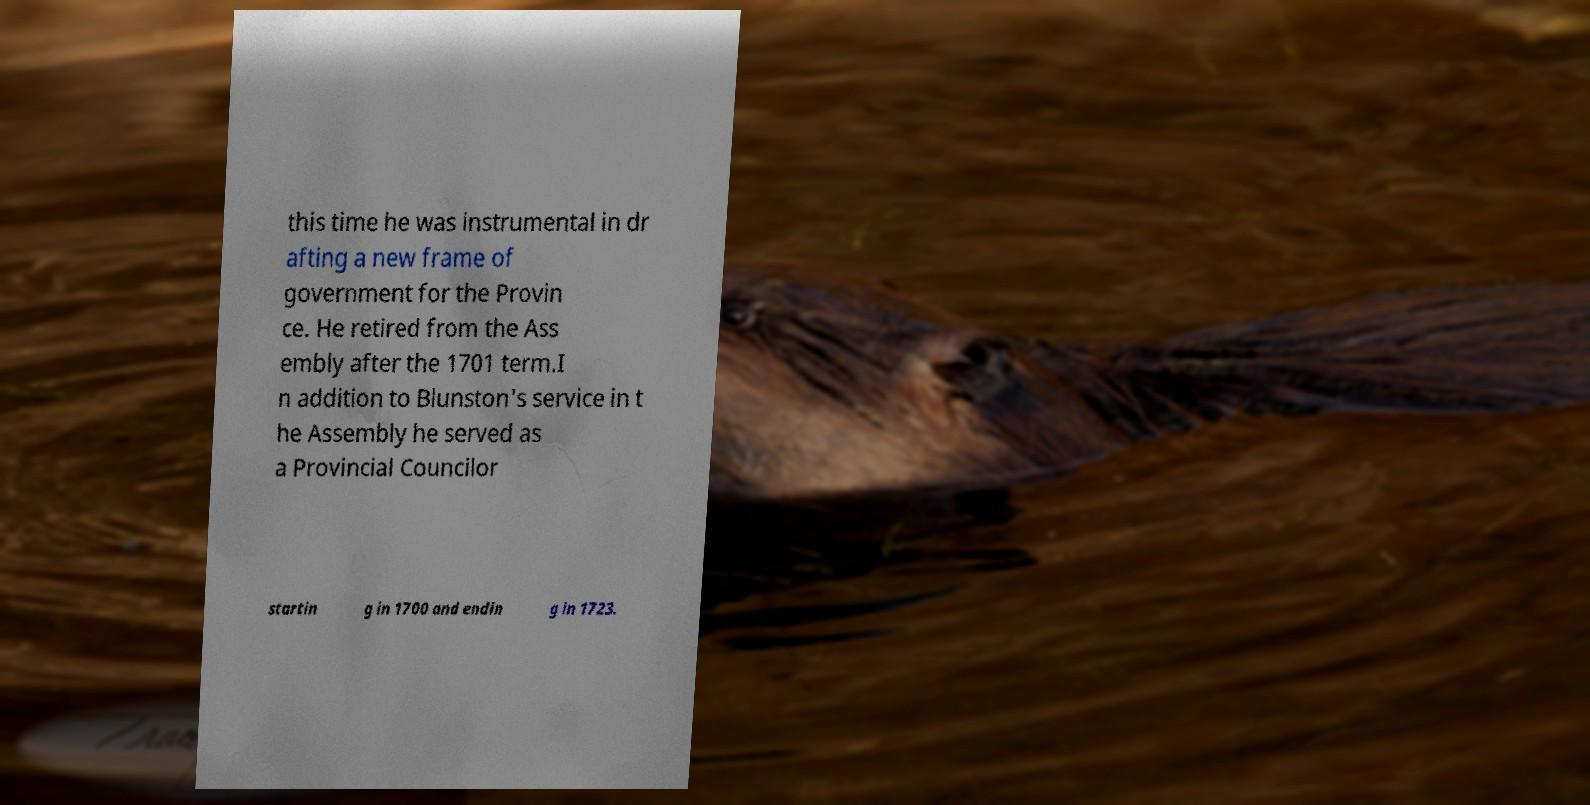Can you accurately transcribe the text from the provided image for me? this time he was instrumental in dr afting a new frame of government for the Provin ce. He retired from the Ass embly after the 1701 term.I n addition to Blunston's service in t he Assembly he served as a Provincial Councilor startin g in 1700 and endin g in 1723. 